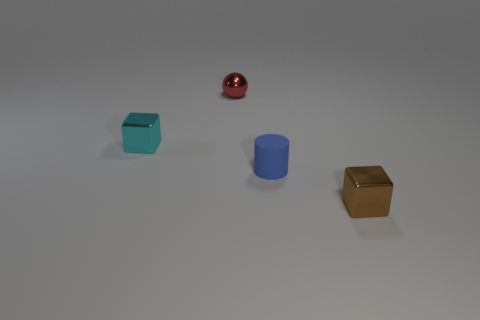Is there anything else that is the same color as the cylinder?
Give a very brief answer. No. There is a cube that is in front of the small metal block that is behind the rubber object; what is its color?
Your answer should be compact. Brown. There is a brown thing that is made of the same material as the red thing; what size is it?
Offer a terse response. Small. Are there any metallic blocks in front of the tiny blue cylinder that is in front of the small thing that is behind the tiny cyan object?
Offer a very short reply. Yes. What number of green rubber things have the same size as the ball?
Your answer should be very brief. 0. Does the metallic block that is right of the blue rubber thing have the same size as the cube behind the small blue rubber cylinder?
Provide a short and direct response. Yes. There is a object that is both to the left of the small brown metallic block and on the right side of the red metallic thing; what is its shape?
Provide a succinct answer. Cylinder. Are any small cyan things visible?
Offer a very short reply. Yes. There is a small shiny thing on the right side of the red shiny ball; what is its color?
Provide a short and direct response. Brown. There is a metal thing that is behind the small cylinder and on the right side of the tiny cyan shiny thing; how big is it?
Ensure brevity in your answer.  Small. 